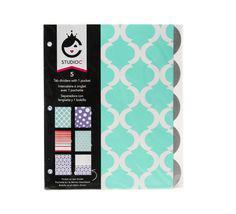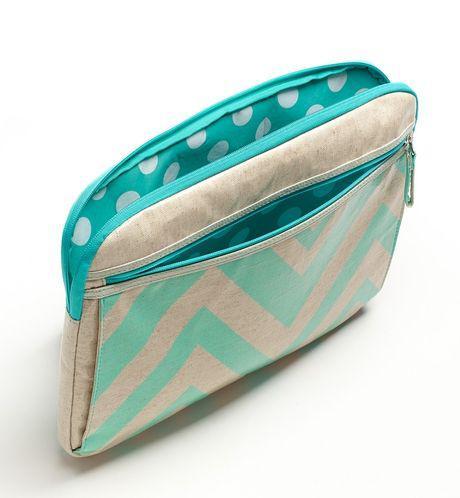The first image is the image on the left, the second image is the image on the right. For the images shown, is this caption "A school supply has a print of a cartoon face in one of the images." true? Answer yes or no. Yes. The first image is the image on the left, the second image is the image on the right. For the images shown, is this caption "A zipper case has a black-and-white zig zag pattern on the bottom and a yellowish band across the top." true? Answer yes or no. No. 